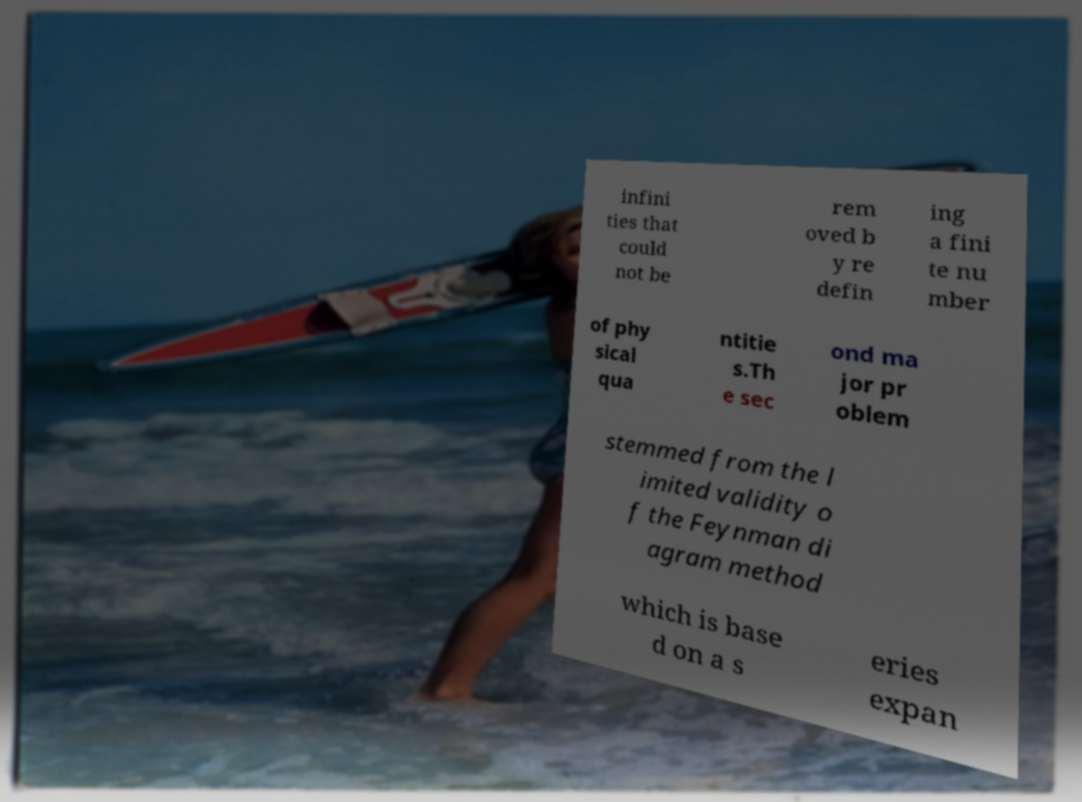Can you read and provide the text displayed in the image?This photo seems to have some interesting text. Can you extract and type it out for me? infini ties that could not be rem oved b y re defin ing a fini te nu mber of phy sical qua ntitie s.Th e sec ond ma jor pr oblem stemmed from the l imited validity o f the Feynman di agram method which is base d on a s eries expan 